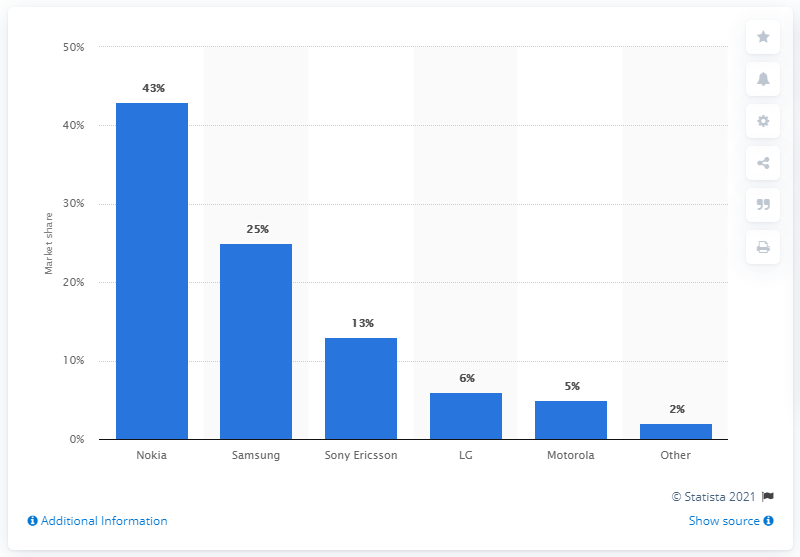Point out several critical features in this image. Nokia is the most popular manufacturer of feature phones. 